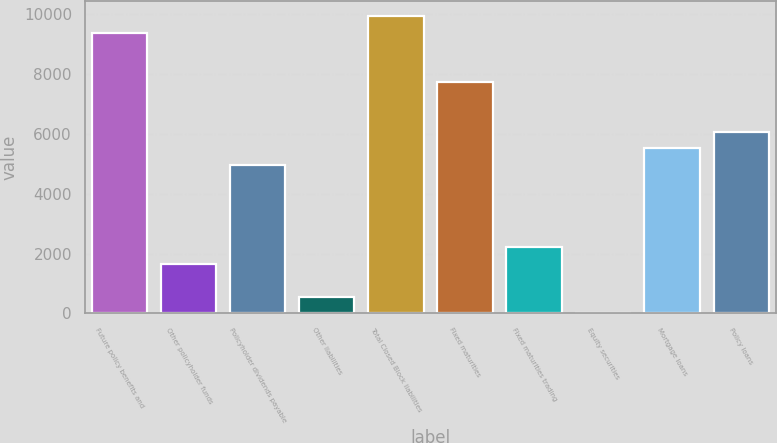<chart> <loc_0><loc_0><loc_500><loc_500><bar_chart><fcel>Future policy benefits and<fcel>Other policyholder funds<fcel>Policyholder dividends payable<fcel>Other liabilities<fcel>Total Closed Block liabilities<fcel>Fixed maturities<fcel>Fixed maturities trading<fcel>Equity securities<fcel>Mortgage loans<fcel>Policy loans<nl><fcel>9374.6<fcel>1666.2<fcel>4969.8<fcel>565<fcel>9925.2<fcel>7722.8<fcel>2216.8<fcel>14.4<fcel>5520.4<fcel>6071<nl></chart> 